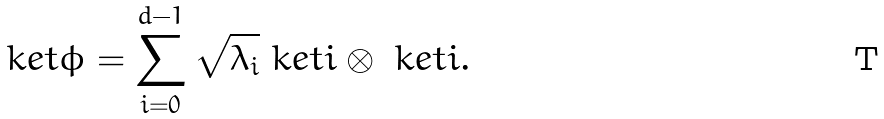Convert formula to latex. <formula><loc_0><loc_0><loc_500><loc_500>\ k e t { \phi } = \sum _ { i = 0 } ^ { d - 1 } \sqrt { \lambda _ { i } } \ k e t { i } \otimes \ k e t { i } .</formula> 